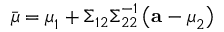<formula> <loc_0><loc_0><loc_500><loc_500>{ \bar { \mu } } = { \mu } _ { 1 } + { \Sigma } _ { 1 2 } { \Sigma } _ { 2 2 } ^ { - 1 } \left ( a - { \mu } _ { 2 } \right )</formula> 